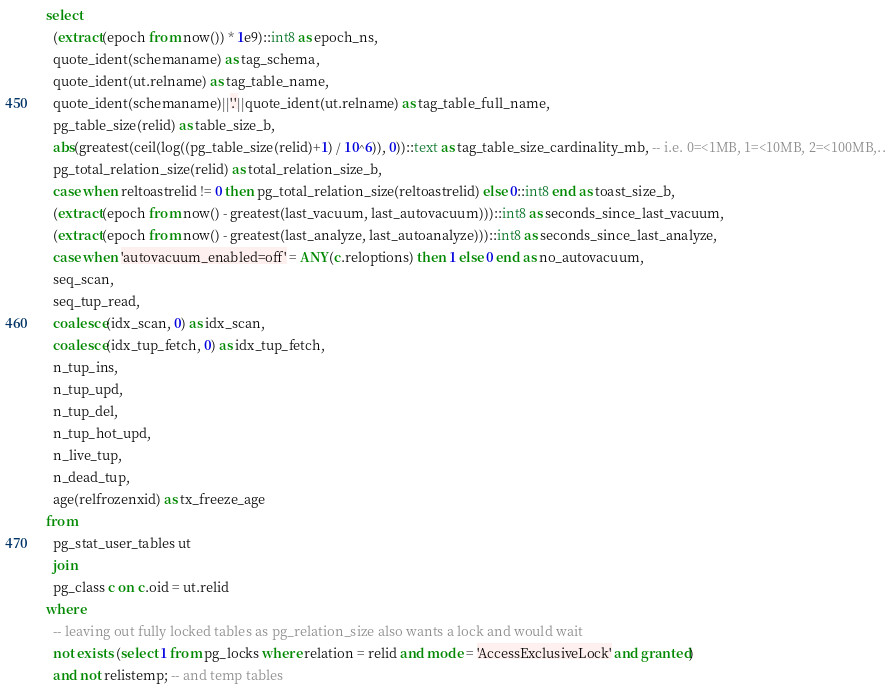<code> <loc_0><loc_0><loc_500><loc_500><_SQL_>select
  (extract(epoch from now()) * 1e9)::int8 as epoch_ns,
  quote_ident(schemaname) as tag_schema,
  quote_ident(ut.relname) as tag_table_name,
  quote_ident(schemaname)||'.'||quote_ident(ut.relname) as tag_table_full_name,
  pg_table_size(relid) as table_size_b,
  abs(greatest(ceil(log((pg_table_size(relid)+1) / 10^6)), 0))::text as tag_table_size_cardinality_mb, -- i.e. 0=<1MB, 1=<10MB, 2=<100MB,..
  pg_total_relation_size(relid) as total_relation_size_b,
  case when reltoastrelid != 0 then pg_total_relation_size(reltoastrelid) else 0::int8 end as toast_size_b,
  (extract(epoch from now() - greatest(last_vacuum, last_autovacuum)))::int8 as seconds_since_last_vacuum,
  (extract(epoch from now() - greatest(last_analyze, last_autoanalyze)))::int8 as seconds_since_last_analyze,
  case when 'autovacuum_enabled=off' = ANY(c.reloptions) then 1 else 0 end as no_autovacuum,
  seq_scan,
  seq_tup_read,
  coalesce(idx_scan, 0) as idx_scan,
  coalesce(idx_tup_fetch, 0) as idx_tup_fetch,
  n_tup_ins,
  n_tup_upd,
  n_tup_del,
  n_tup_hot_upd,
  n_live_tup,
  n_dead_tup,
  age(relfrozenxid) as tx_freeze_age
from
  pg_stat_user_tables ut
  join
  pg_class c on c.oid = ut.relid
where
  -- leaving out fully locked tables as pg_relation_size also wants a lock and would wait
  not exists (select 1 from pg_locks where relation = relid and mode = 'AccessExclusiveLock' and granted)
  and not relistemp; -- and temp tables
</code> 